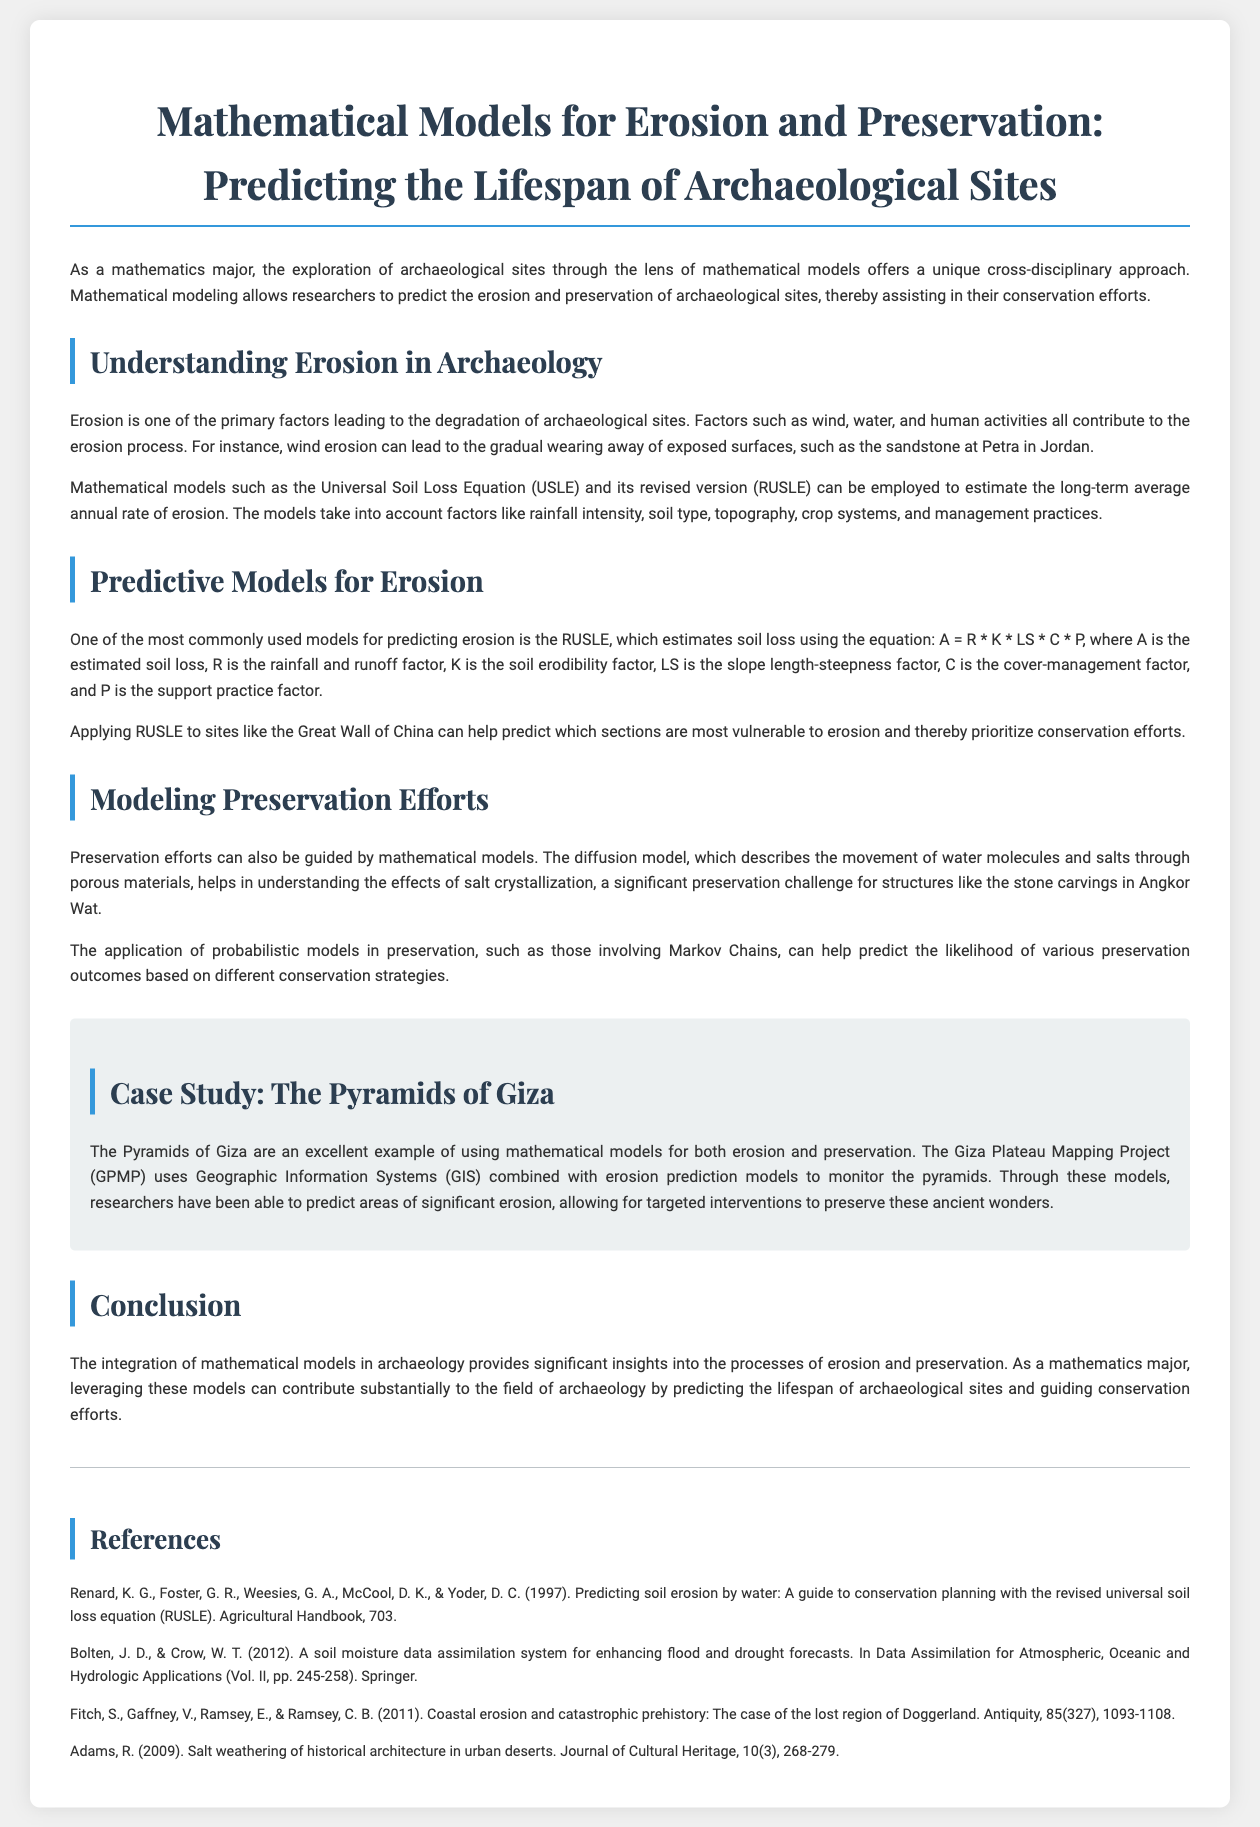What is the primary factor leading to the degradation of archaeological sites? Erosion is identified in the document as the primary factor contributing to the degradation of archaeological sites.
Answer: Erosion What mathematical model is used to estimate soil loss? The document mentions the Universal Soil Loss Equation, specifically the revised version (RUSLE), as a model for estimating soil loss.
Answer: RUSLE What is the equation used in the RUSLE model? The document states the RUSLE equation is A = R * K * LS * C * P.
Answer: A = R * K * LS * C * P What significant preservation challenge is mentioned in relation to Angkor Wat? The document refers to salt crystallization as a significant preservation challenge for structures like the stone carvings in Angkor Wat.
Answer: Salt crystallization Which archaeological site is highlighted in the case study? The Pyramids of Giza are specifically emphasized in the case study section of the document.
Answer: The Pyramids of Giza What technology is combined with erosion prediction models in the Giza Plateau Mapping Project? The document indicates that Geographic Information Systems (GIS) are combined with erosion prediction models in the Giza Plateau Mapping Project.
Answer: Geographic Information Systems (GIS) How does the diffusion model contribute to preservation efforts? The diffusion model is discussed in the document as a tool for understanding the movement of water molecules and salts, aiding in preservation strategies.
Answer: Movement of water molecules and salts What is the last section of the document titled? The final section of the document is titled “Conclusion.”
Answer: Conclusion What type of modeling is used to predict preservation outcomes based on different strategies? The document mentions the use of probabilistic models, specifically Markov Chains, to predict preservation outcomes.
Answer: Markov Chains 